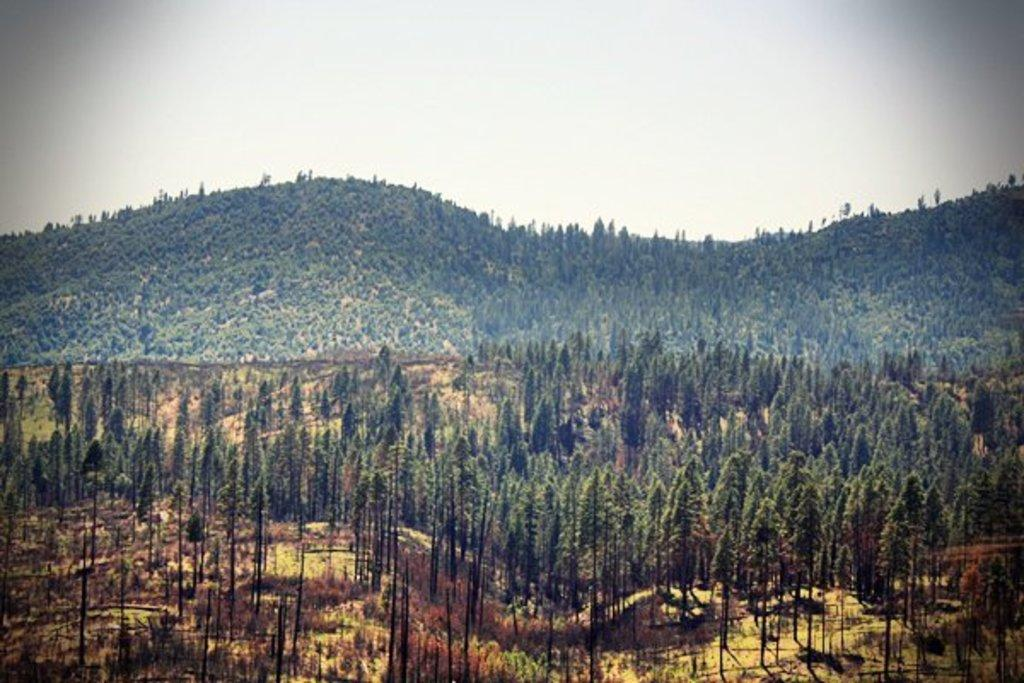What type of vegetation can be seen in the image? There are trees in the image. What geographical features are present in the image? There are hills in the image. Where is the rifle hidden in the image? There is no rifle present in the image. What type of vein can be seen in the image? There are no veins visible in the image; it features trees and hills. 